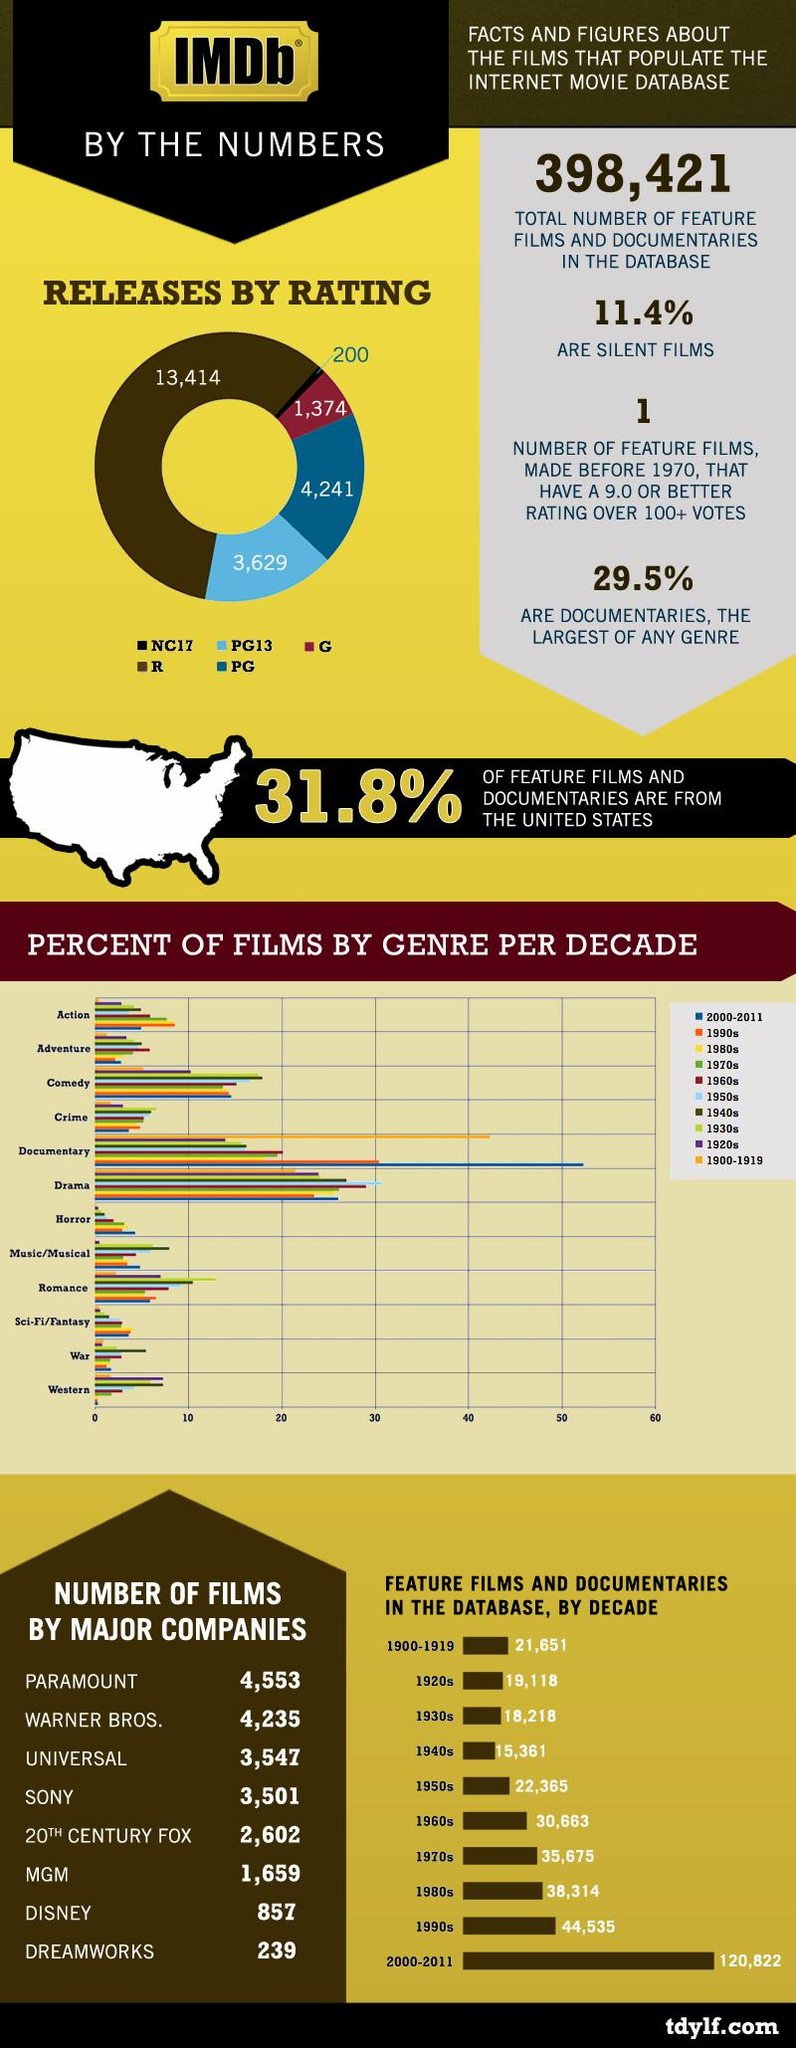List a handful of essential elements in this visual. There were 200 films released on the internet that were rated NC17. The collaboration between Disney and MGM resulted in the production of 2,516 films. The 1980s ranks third in the number of feature films and documentaries produced. In 1990, more movies of the documentary genre were released than any other genre. The 2000s had the highest number of horror movies. 